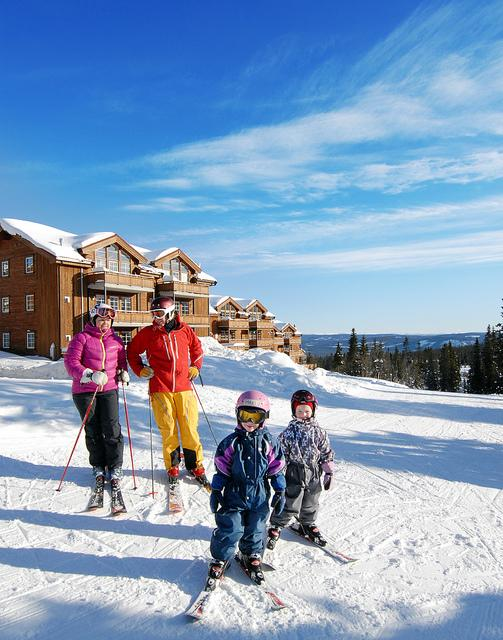Who are the adults standing behind the children? Please explain your reasoning. parents. There is a man and a woman. 